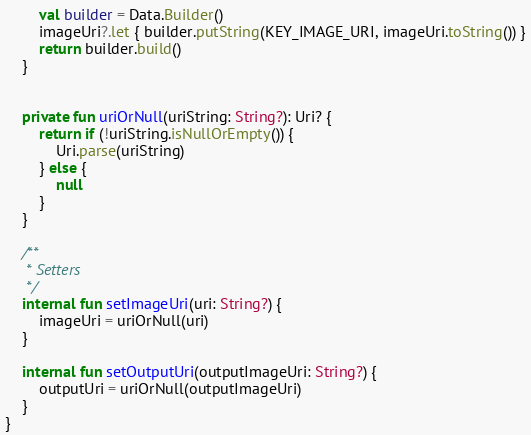Convert code to text. <code><loc_0><loc_0><loc_500><loc_500><_Kotlin_>        val builder = Data.Builder()
        imageUri?.let { builder.putString(KEY_IMAGE_URI, imageUri.toString()) }
        return builder.build()
    }


    private fun uriOrNull(uriString: String?): Uri? {
        return if (!uriString.isNullOrEmpty()) {
            Uri.parse(uriString)
        } else {
            null
        }
    }

    /**
     * Setters
     */
    internal fun setImageUri(uri: String?) {
        imageUri = uriOrNull(uri)
    }

    internal fun setOutputUri(outputImageUri: String?) {
        outputUri = uriOrNull(outputImageUri)
    }
}
</code> 